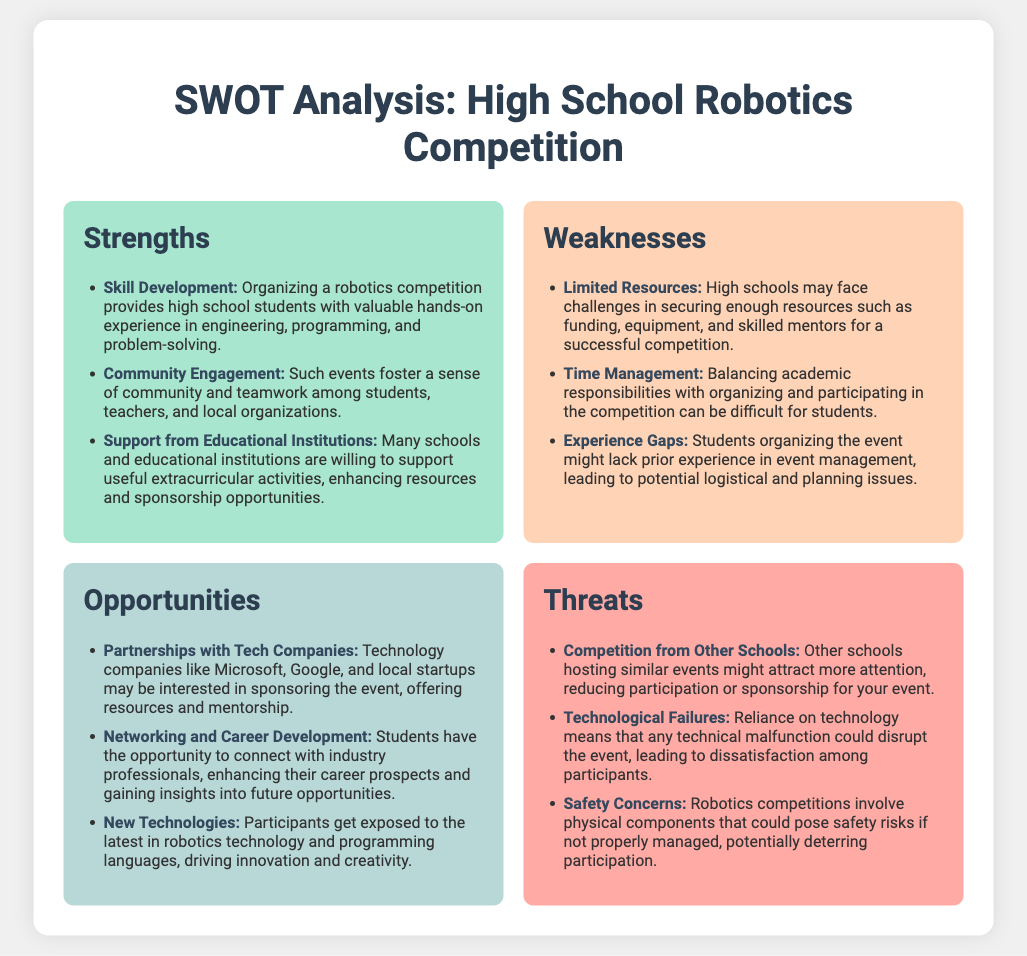What is one strength of organizing a robotics competition? The document lists several strengths, one of which is that it provides high school students with valuable hands-on experience.
Answer: Skill Development How many weaknesses are identified in the document? The document outlines three weaknesses related to organizing the competition.
Answer: 3 What opportunity involves connections with industry professionals? The document specifies an opportunity that allows students to connect with professionals, enhancing their career prospects.
Answer: Networking and Career Development What is a potential threat listed about technology? One threat mentioned is related to technology failures that could disrupt the event.
Answer: Technological Failures Which educational support is mentioned as a strength? The document notes that many schools are willing to support useful extracurricular activities.
Answer: Support from Educational Institutions 